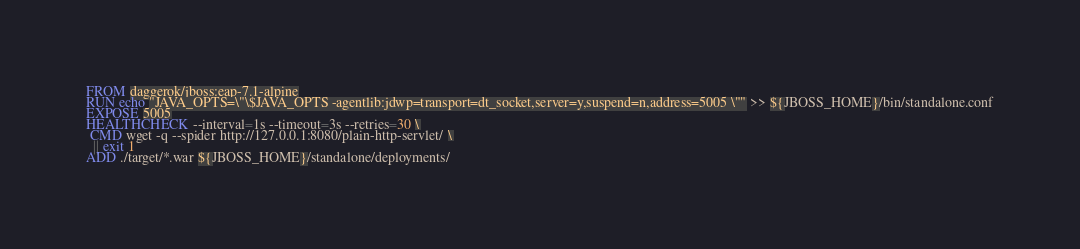<code> <loc_0><loc_0><loc_500><loc_500><_Dockerfile_>FROM daggerok/jboss:eap-7.1-alpine
RUN echo "JAVA_OPTS=\"\$JAVA_OPTS -agentlib:jdwp=transport=dt_socket,server=y,suspend=n,address=5005 \"" >> ${JBOSS_HOME}/bin/standalone.conf
EXPOSE 5005
HEALTHCHECK --interval=1s --timeout=3s --retries=30 \
 CMD wget -q --spider http://127.0.0.1:8080/plain-http-servlet/ \
  || exit 1
ADD ./target/*.war ${JBOSS_HOME}/standalone/deployments/
</code> 